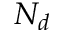Convert formula to latex. <formula><loc_0><loc_0><loc_500><loc_500>N _ { d }</formula> 